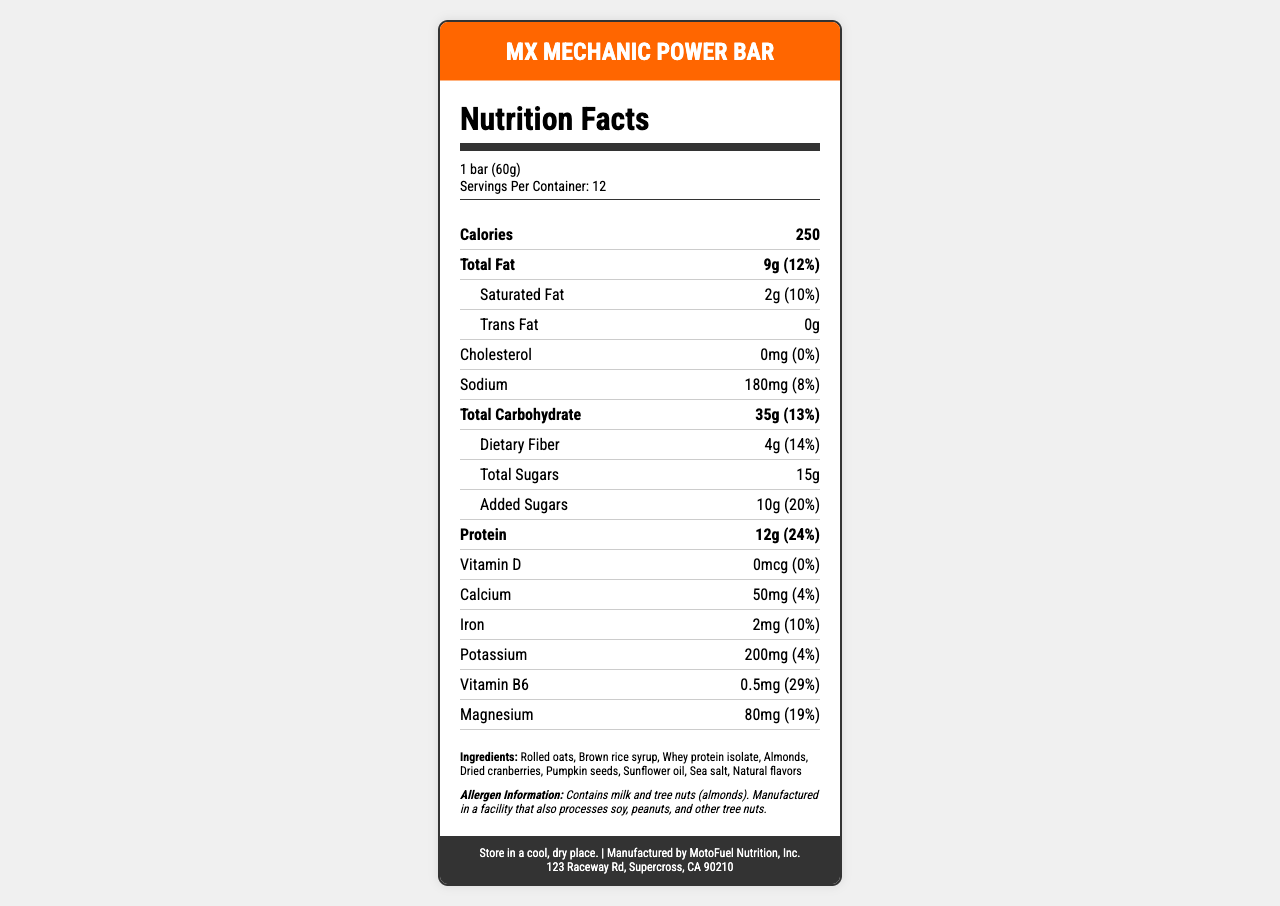what is the product name? The product name is clearly mentioned at the top of the document and in the title section.
Answer: MX Mechanic Power Bar how much protein is in one serving? The nutrition facts section states that one bar contains 12g of protein.
Answer: 12g what is the serving size? The serving size is listed as "1 bar (60g)" in the serving information section.
Answer: 1 bar (60g) how many servings are in one container? The document states that there are 12 servings per container.
Answer: 12 what is the amount of dietary fiber per serving? The amount of dietary fiber per serving is listed as 4g in the nutrition facts.
Answer: 4g does the product contain any allergens? The allergen information section states that the product contains milk and tree nuts (almonds).
Answer: Yes what ingredients are included in the bar? The ingredients are listed in the ingredients section of the document.
Answer: Rolled oats, Brown rice syrup, Whey protein isolate, Almonds, Dried cranberries, Pumpkin seeds, Sunflower oil, Sea salt, Natural flavors how much iron is in each serving? The nutrition facts section indicates that each bar contains 2mg of iron.
Answer: 2mg where should the product be stored? The storage instructions at the end of the document advise storing the product in a cool, dry place.
Answer: In a cool, dry place who is the manufacturer of this product? The manufacturer is listed as MotoFuel Nutrition, Inc. in the footer of the document.
Answer: MotoFuel Nutrition, Inc. which of the following nutrients is present in the highest amount per serving? A. Sodium B. Dietary Fiber C. Protein D. Added Sugars The document lists 12g of protein, which is higher than the amounts of sodium (180mg), dietary fiber (4g), and added sugars (10g).
Answer: C. Protein what percentage of the daily value for Vitamin B6 does one serving provide? A. 4% B. 10% C. 19% D. 29% The document indicates that one serving provides 29% of the daily value for Vitamin B6.
Answer: D. 29% is there any trans fat in the product? The nutrition facts section clearly shows that the trans fat content is 0g.
Answer: No summarize the main information provided in the document. This document provides comprehensive nutrition information, ingredient details, and additional product information relevant to the MX Mechanic Power Bar.
Answer: The document details the nutrition facts, ingredients, allergen information, and storage instructions for the MX Mechanic Power Bar. Each bar has a serving size of 60g, contains 250 calories, and includes various nutrients such as 12g of protein, 9g of total fat, 35g of carbohydrates, and 4g of dietary fiber. The bar also includes vitamins and minerals like calcium, iron, potassium, Vitamin B6, and magnesium. The ingredients are listed, and it is noted that the product contains milk and tree nuts (almonds). Manufactured by MotoFuel Nutrition, Inc., the bar should be stored in a cool, dry place. what is the exact address of the manufacturer? The manufacturer's address is provided at the bottom of the document.
Answer: 123 Raceway Rd, Supercross, CA 90210 does the product contain wheat? The allergen information mentions milk and tree nuts but does not mention wheat specifically. Hence, it cannot be determined from the given document.
Answer: Not enough information 